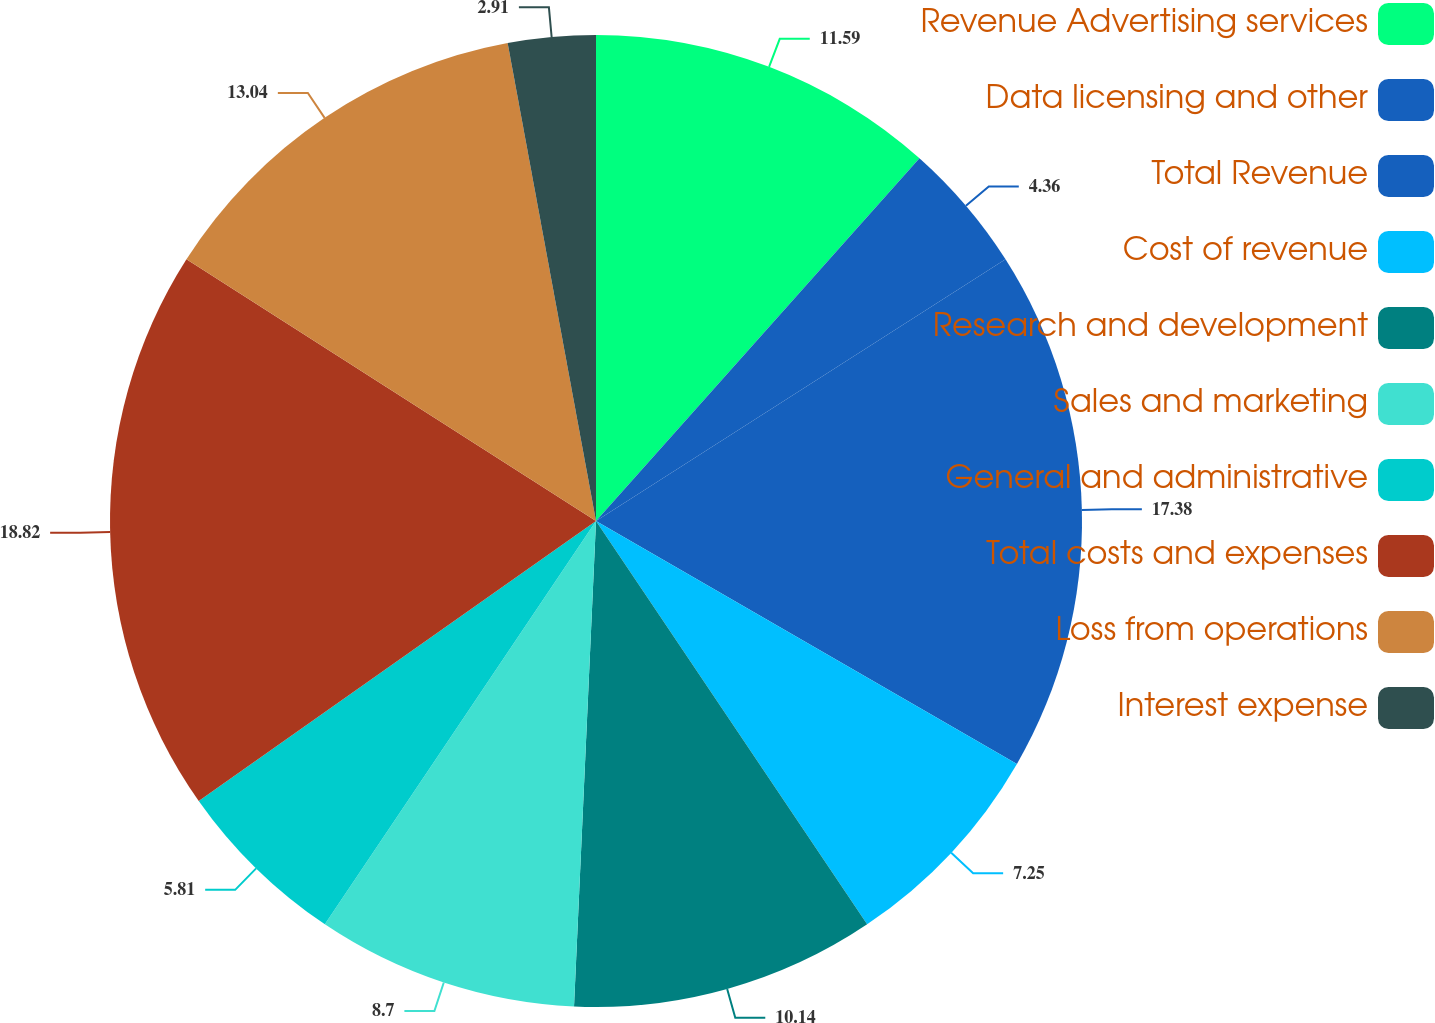Convert chart to OTSL. <chart><loc_0><loc_0><loc_500><loc_500><pie_chart><fcel>Revenue Advertising services<fcel>Data licensing and other<fcel>Total Revenue<fcel>Cost of revenue<fcel>Research and development<fcel>Sales and marketing<fcel>General and administrative<fcel>Total costs and expenses<fcel>Loss from operations<fcel>Interest expense<nl><fcel>11.59%<fcel>4.36%<fcel>17.38%<fcel>7.25%<fcel>10.14%<fcel>8.7%<fcel>5.81%<fcel>18.82%<fcel>13.04%<fcel>2.91%<nl></chart> 